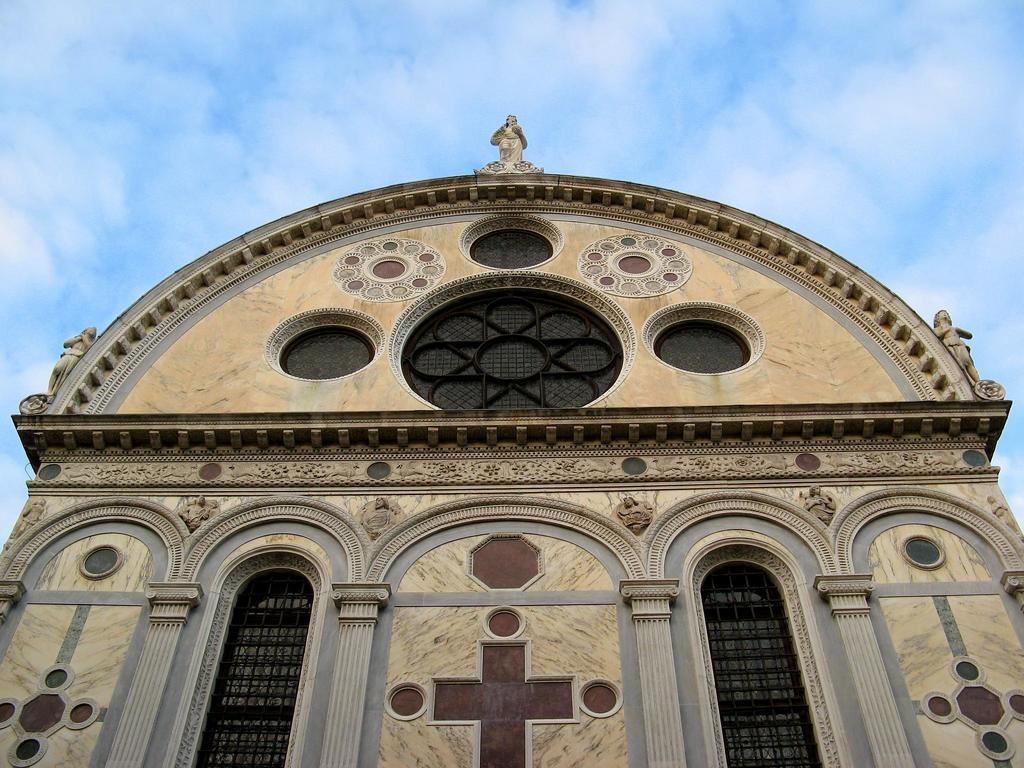What is the main subject in the foreground of the image? There is a building in the foreground of the image. What specific features can be observed on the building? The building has windows. What can be seen in the background of the image? The sky is visible in the background of the image. What is the condition of the sky in the image? There are clouds in the sky. How many screws can be seen holding the building together in the image? There are no screws visible in the image, as the building's construction is not detailed enough to show individual screws. What type of meal is being prepared in the image? There is no meal preparation visible in the image; it primarily features a building and the sky. 